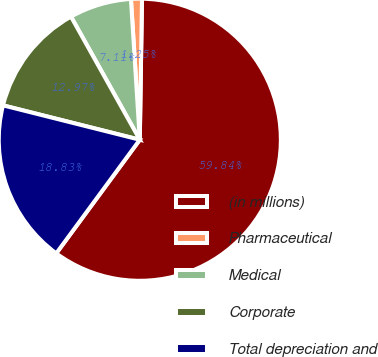Convert chart. <chart><loc_0><loc_0><loc_500><loc_500><pie_chart><fcel>(in millions)<fcel>Pharmaceutical<fcel>Medical<fcel>Corporate<fcel>Total depreciation and<nl><fcel>59.85%<fcel>1.25%<fcel>7.11%<fcel>12.97%<fcel>18.83%<nl></chart> 